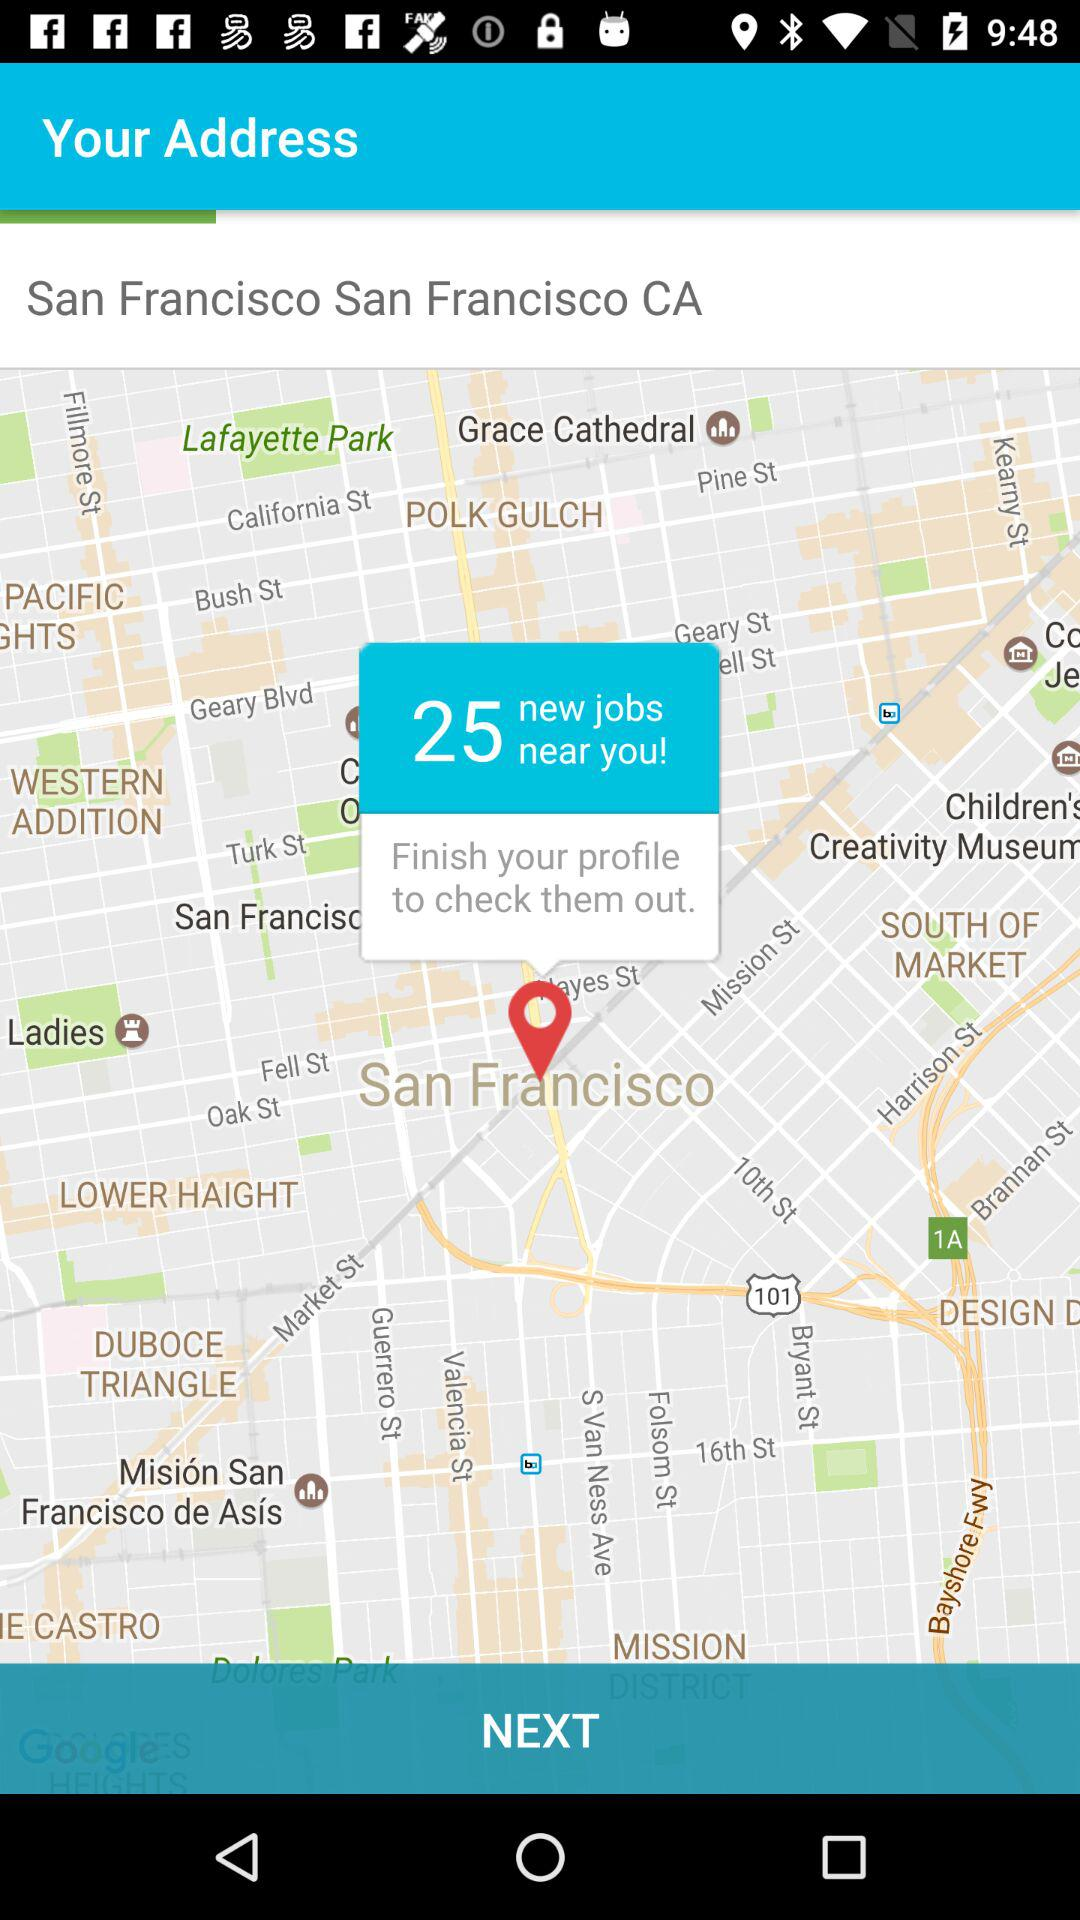What is the given address? The given address is San Francisco San Francisco, CA. 